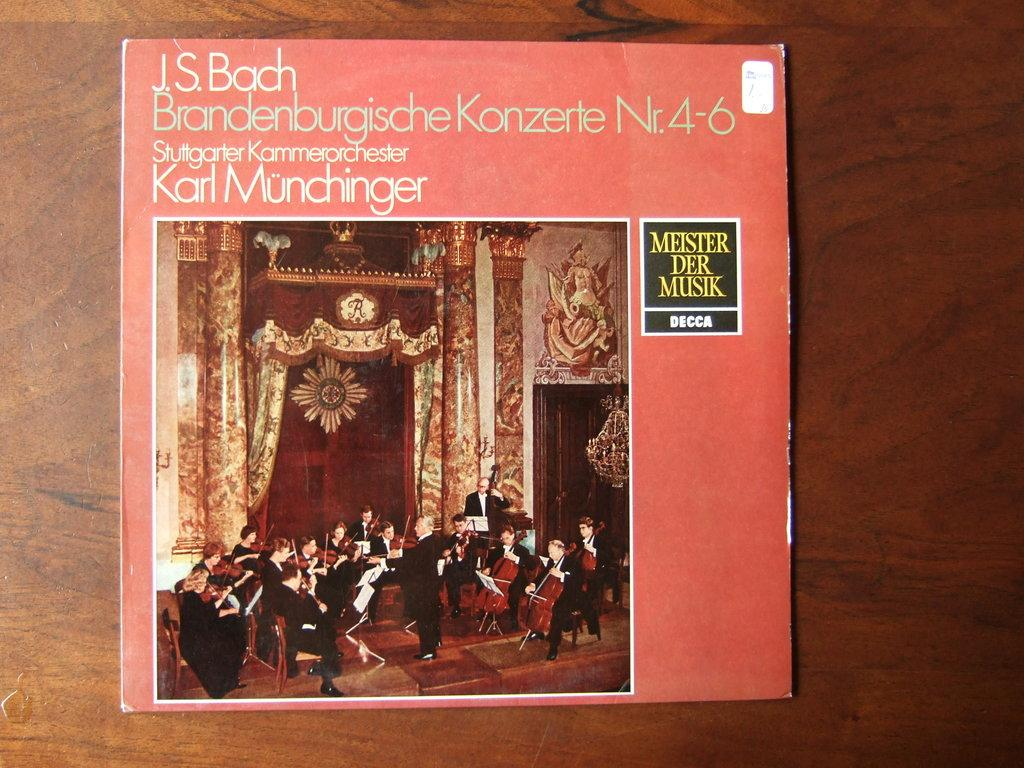<image>
Write a terse but informative summary of the picture. A peach colored album cover with JS Bach on the front list. 